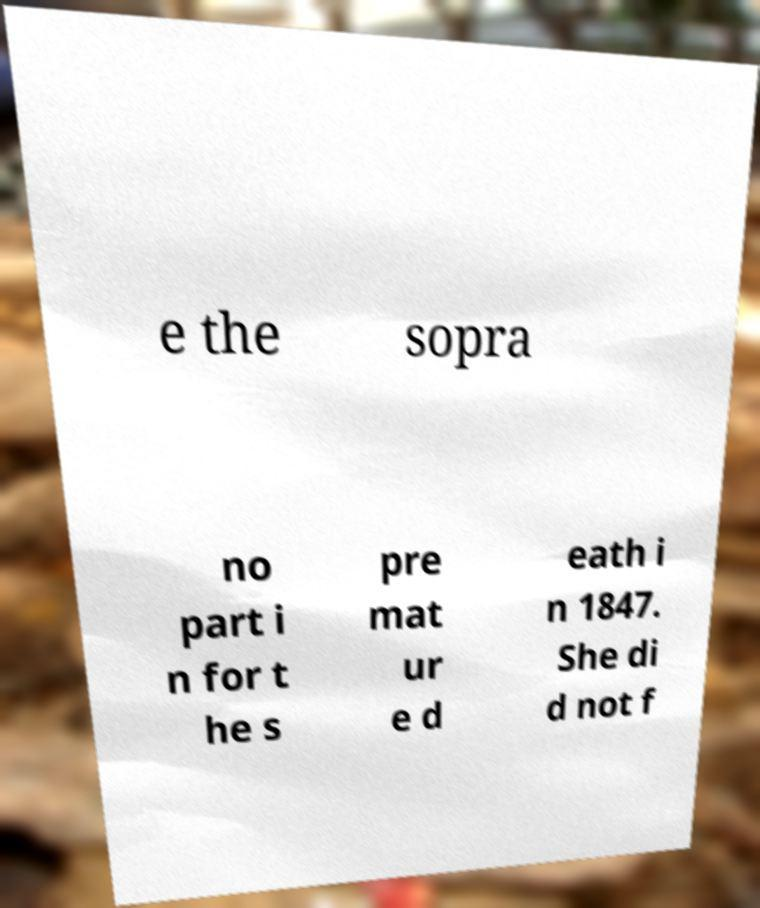Please read and relay the text visible in this image. What does it say? e the sopra no part i n for t he s pre mat ur e d eath i n 1847. She di d not f 